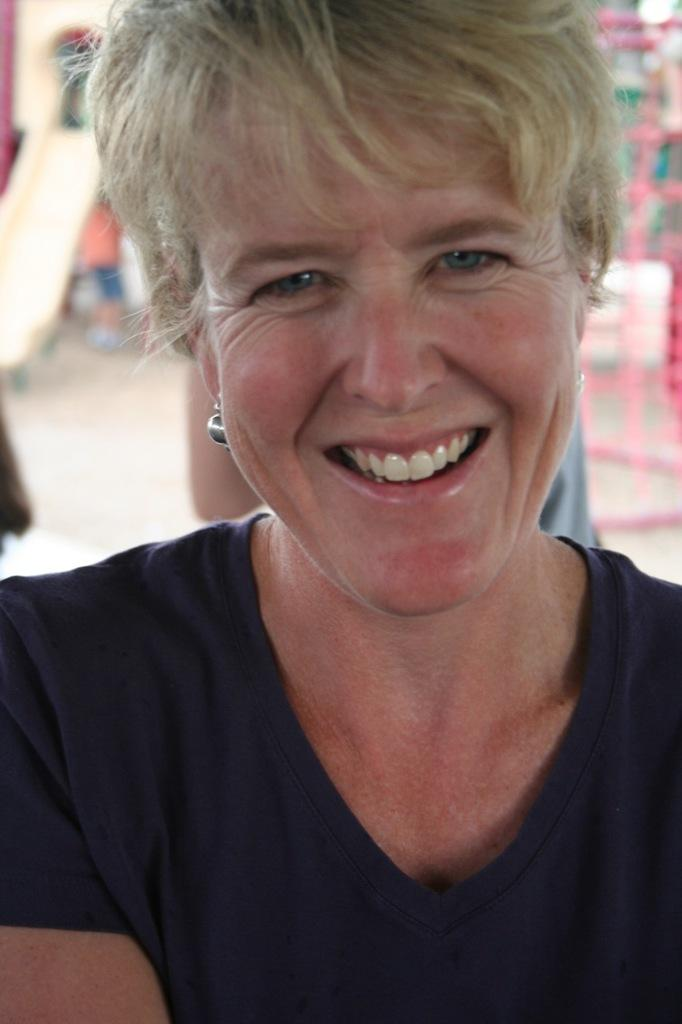What is the main subject of the image? There is a person in the image. What is the person wearing? The person is wearing a t-shirt. What can be seen behind the person? There is a slide behind the person. Can you describe the background of the image? The background of the image is blurred. What type of pump is being used by the person in the image? There is no pump present in the image. 